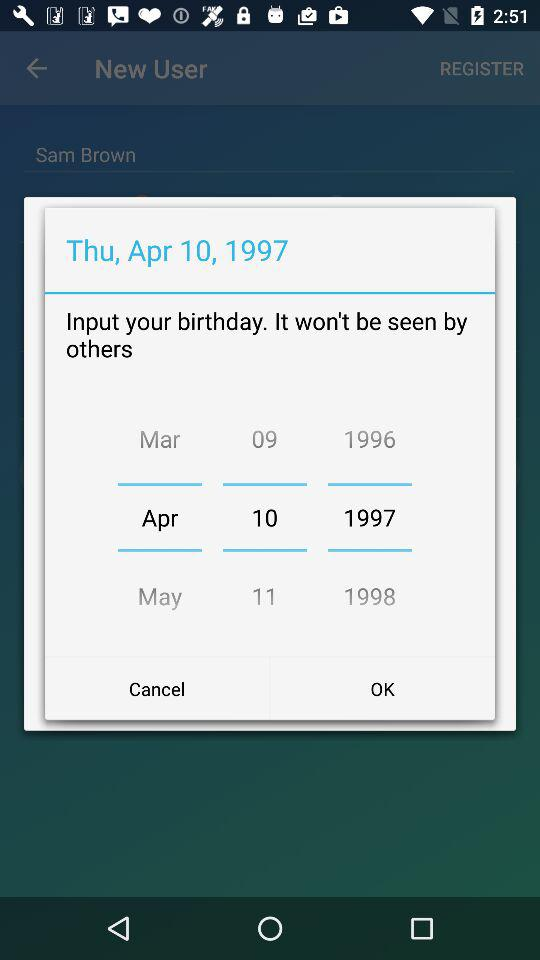How many years are between 1996 and 1997?
Answer the question using a single word or phrase. 1 